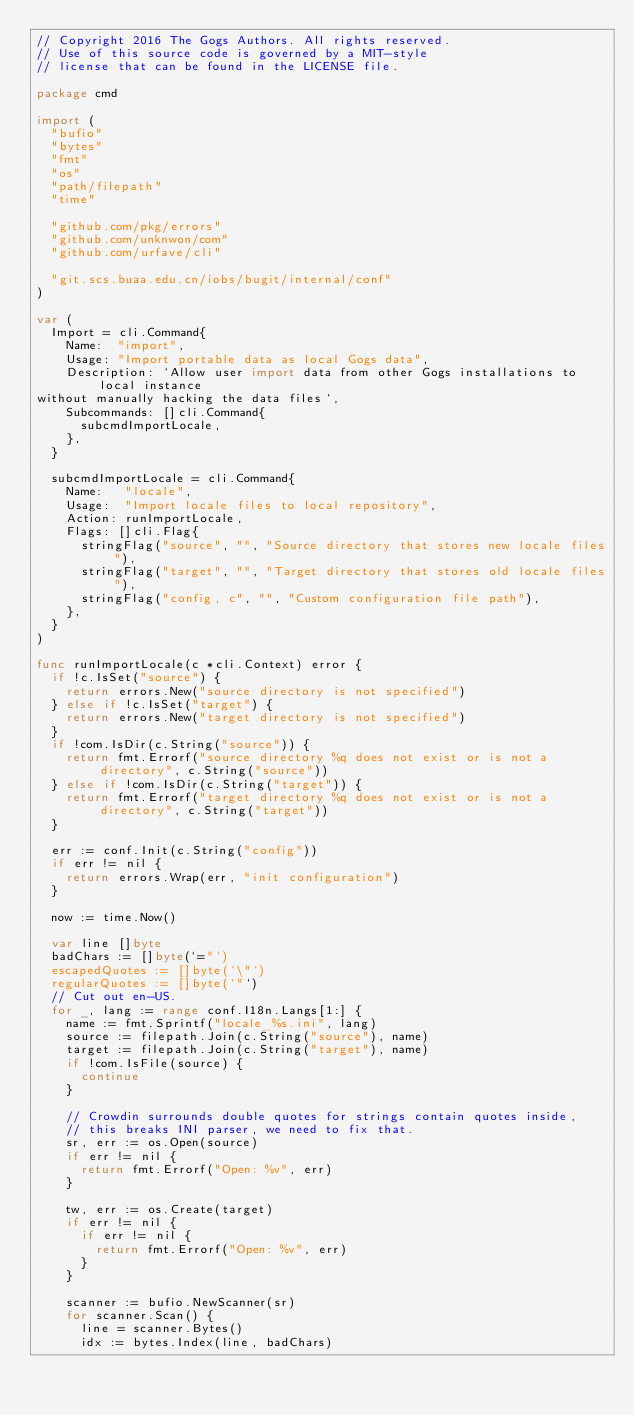<code> <loc_0><loc_0><loc_500><loc_500><_Go_>// Copyright 2016 The Gogs Authors. All rights reserved.
// Use of this source code is governed by a MIT-style
// license that can be found in the LICENSE file.

package cmd

import (
	"bufio"
	"bytes"
	"fmt"
	"os"
	"path/filepath"
	"time"

	"github.com/pkg/errors"
	"github.com/unknwon/com"
	"github.com/urfave/cli"

	"git.scs.buaa.edu.cn/iobs/bugit/internal/conf"
)

var (
	Import = cli.Command{
		Name:  "import",
		Usage: "Import portable data as local Gogs data",
		Description: `Allow user import data from other Gogs installations to local instance
without manually hacking the data files`,
		Subcommands: []cli.Command{
			subcmdImportLocale,
		},
	}

	subcmdImportLocale = cli.Command{
		Name:   "locale",
		Usage:  "Import locale files to local repository",
		Action: runImportLocale,
		Flags: []cli.Flag{
			stringFlag("source", "", "Source directory that stores new locale files"),
			stringFlag("target", "", "Target directory that stores old locale files"),
			stringFlag("config, c", "", "Custom configuration file path"),
		},
	}
)

func runImportLocale(c *cli.Context) error {
	if !c.IsSet("source") {
		return errors.New("source directory is not specified")
	} else if !c.IsSet("target") {
		return errors.New("target directory is not specified")
	}
	if !com.IsDir(c.String("source")) {
		return fmt.Errorf("source directory %q does not exist or is not a directory", c.String("source"))
	} else if !com.IsDir(c.String("target")) {
		return fmt.Errorf("target directory %q does not exist or is not a directory", c.String("target"))
	}

	err := conf.Init(c.String("config"))
	if err != nil {
		return errors.Wrap(err, "init configuration")
	}

	now := time.Now()

	var line []byte
	badChars := []byte(`="`)
	escapedQuotes := []byte(`\"`)
	regularQuotes := []byte(`"`)
	// Cut out en-US.
	for _, lang := range conf.I18n.Langs[1:] {
		name := fmt.Sprintf("locale_%s.ini", lang)
		source := filepath.Join(c.String("source"), name)
		target := filepath.Join(c.String("target"), name)
		if !com.IsFile(source) {
			continue
		}

		// Crowdin surrounds double quotes for strings contain quotes inside,
		// this breaks INI parser, we need to fix that.
		sr, err := os.Open(source)
		if err != nil {
			return fmt.Errorf("Open: %v", err)
		}

		tw, err := os.Create(target)
		if err != nil {
			if err != nil {
				return fmt.Errorf("Open: %v", err)
			}
		}

		scanner := bufio.NewScanner(sr)
		for scanner.Scan() {
			line = scanner.Bytes()
			idx := bytes.Index(line, badChars)</code> 